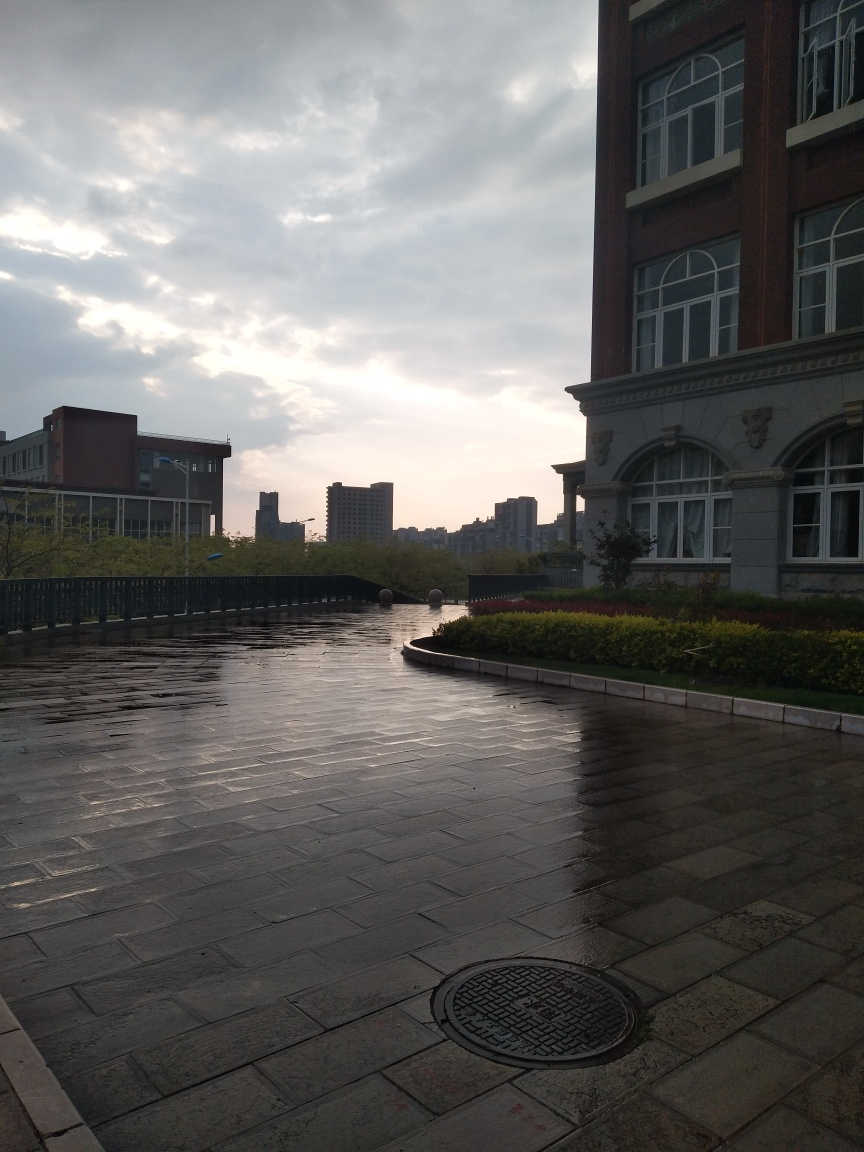Can you describe the weather conditions at the time this photo was taken? The weather appears to be overcast with breaking clouds, indicative of the aftermath of a rain shower. The dampness on the pavement reflects the sky, hinting at recent rainfall which has likely just ceased. 